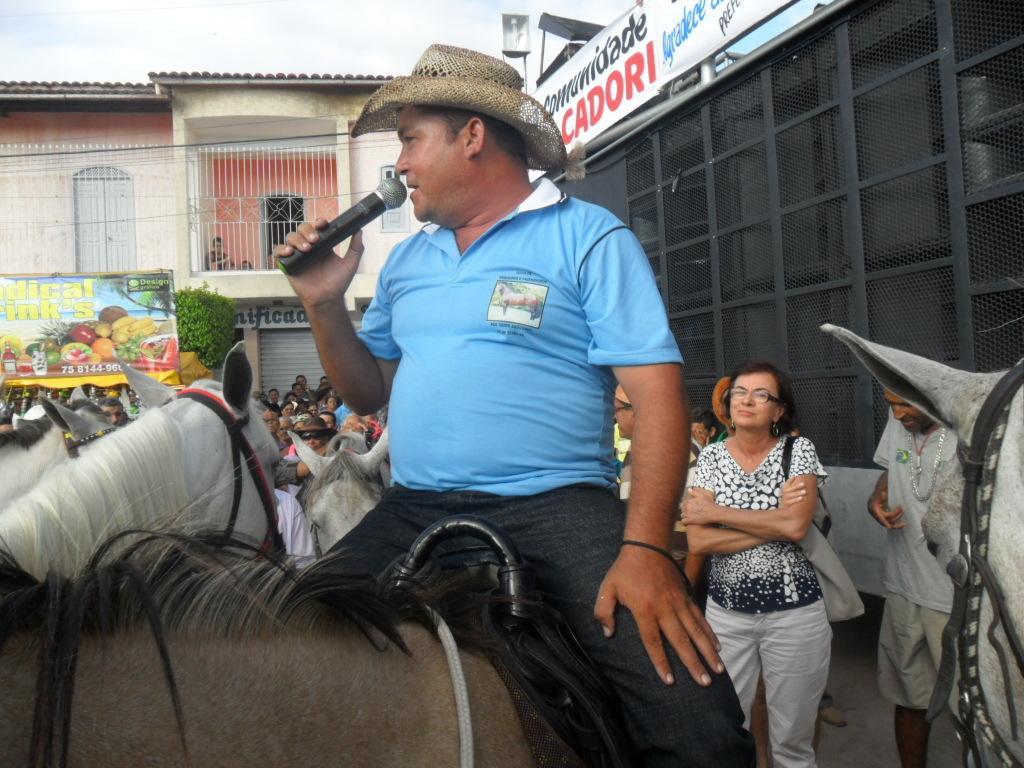Describe this image in one or two sentences. This picture is taken on a road. There are people and horses on road. In the center there is a man sitting on a horse wearing a hat and holding a microphone in his hand. To the extreme left corner there is a board and on it text and fruit images are there. In the background there are plants, buildings, doors, railing and sky. 